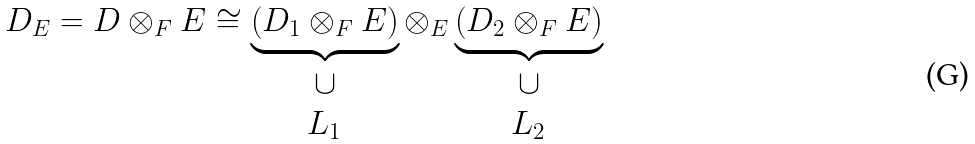Convert formula to latex. <formula><loc_0><loc_0><loc_500><loc_500>D _ { E } = D \otimes _ { F } E \cong \underbrace { \left ( D _ { 1 } \otimes _ { F } E \right ) } _ { \begin{array} { c } \cup \\ L _ { 1 } \end{array} } \otimes _ { E } \underbrace { \left ( D _ { 2 } \otimes _ { F } E \right ) } _ { \begin{array} { c } \cup \\ L _ { 2 } \end{array} }</formula> 